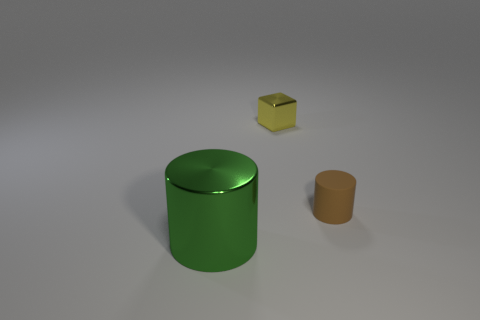Subtract all blocks. How many objects are left? 2 Subtract all brown cylinders. How many cylinders are left? 1 Subtract 1 cylinders. How many cylinders are left? 1 Add 2 large cylinders. How many large cylinders are left? 3 Add 3 large green things. How many large green things exist? 4 Add 1 shiny objects. How many objects exist? 4 Subtract 0 brown blocks. How many objects are left? 3 Subtract all brown cylinders. Subtract all yellow spheres. How many cylinders are left? 1 Subtract all purple blocks. How many brown cylinders are left? 1 Subtract all big green things. Subtract all tiny brown objects. How many objects are left? 1 